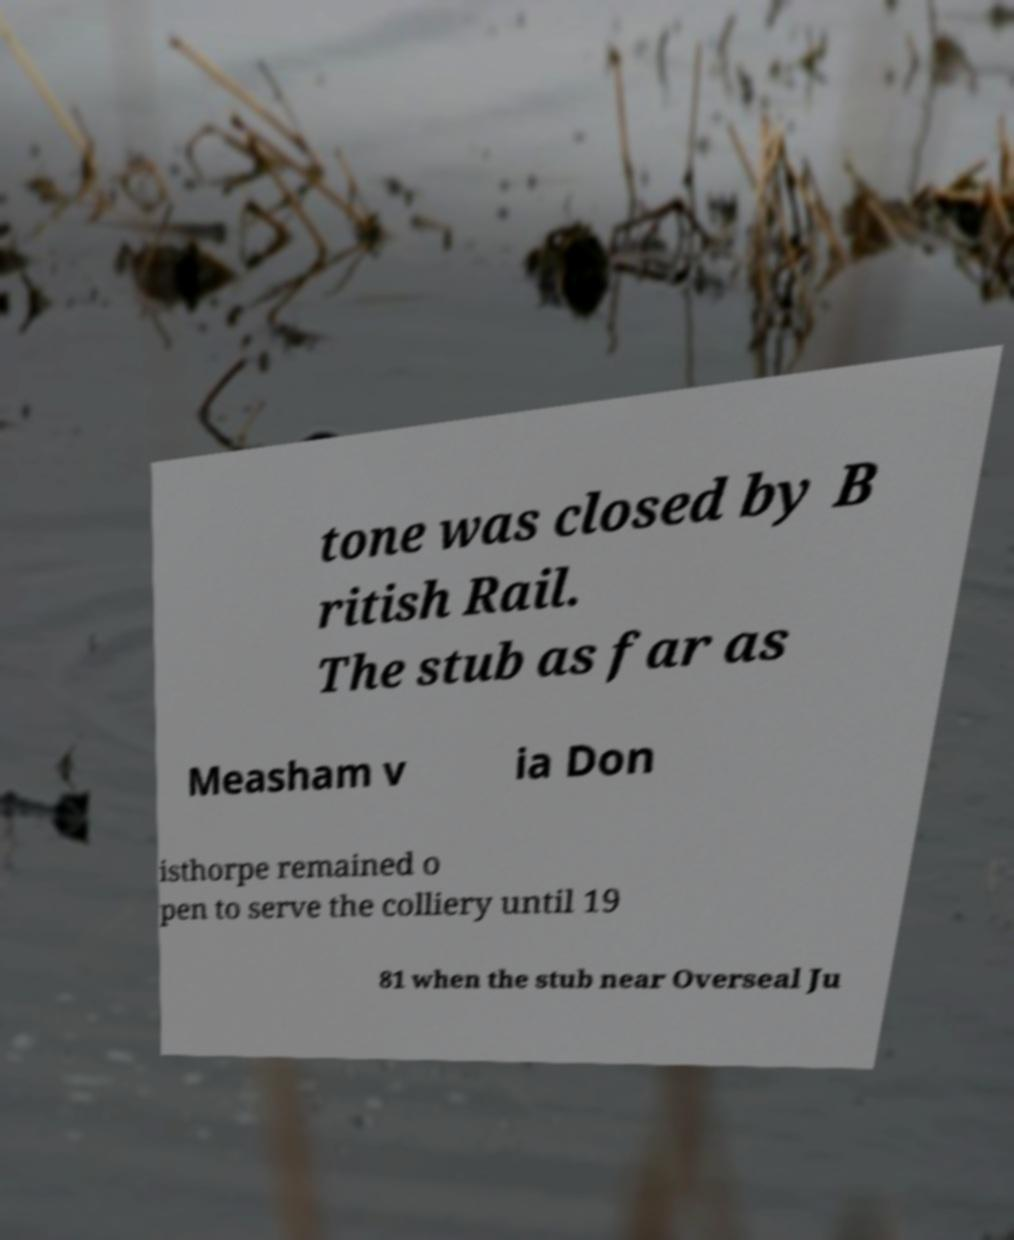There's text embedded in this image that I need extracted. Can you transcribe it verbatim? tone was closed by B ritish Rail. The stub as far as Measham v ia Don isthorpe remained o pen to serve the colliery until 19 81 when the stub near Overseal Ju 